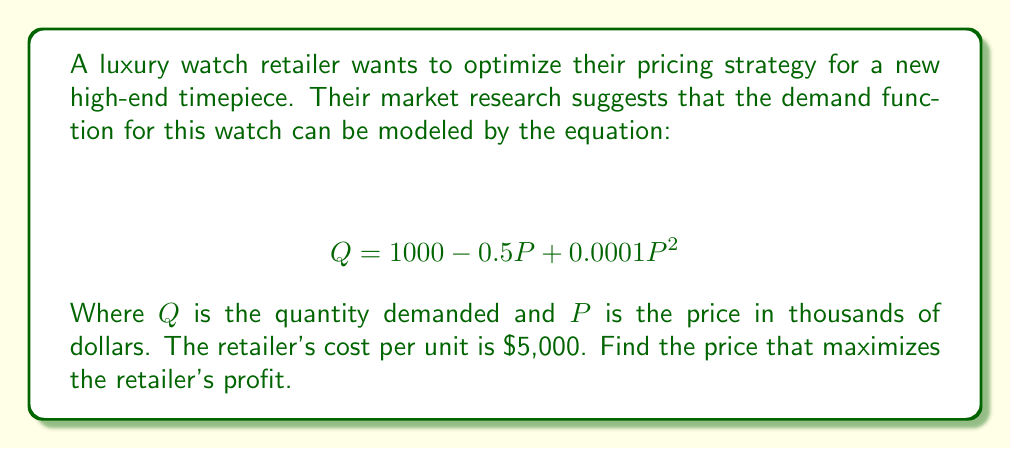Show me your answer to this math problem. To find the price that maximizes profit, we need to follow these steps:

1) First, let's define the profit function. Profit is revenue minus cost:
   $$ \text{Profit} = \text{Revenue} - \text{Cost} $$

2) Revenue is price times quantity:
   $$ \text{Revenue} = P \cdot Q = P(1000 - 0.5P + 0.0001P^2) $$

3) Cost is the cost per unit times quantity:
   $$ \text{Cost} = 5 \cdot Q = 5(1000 - 0.5P + 0.0001P^2) $$

4) Now we can write our profit function:
   $$ \text{Profit} = P(1000 - 0.5P + 0.0001P^2) - 5(1000 - 0.5P + 0.0001P^2) $$

5) Simplify:
   $$ \text{Profit} = 1000P - 0.5P^2 + 0.0001P^3 - 5000 + 2.5P - 0.0005P^2 $$
   $$ \text{Profit} = -5000 + 1002.5P - 0.5005P^2 + 0.0001P^3 $$

6) To find the maximum profit, we need to find where the derivative of the profit function equals zero:
   $$ \frac{d(\text{Profit})}{dP} = 1002.5 - 1.001P + 0.0003P^2 = 0 $$

7) This is a quadratic equation. We can solve it using the quadratic formula:
   $$ P = \frac{-b \pm \sqrt{b^2 - 4ac}}{2a} $$
   Where $a = 0.0003$, $b = -1.001$, and $c = 1002.5$

8) Solving this equation:
   $$ P \approx 10.01 \text{ or } 3330.99 $$

9) The second solution is unrealistic for a watch price, so we choose the first solution.

10) To confirm this is a maximum (not a minimum), we can check that the second derivative is negative at this point, which it is.
Answer: $10,010 